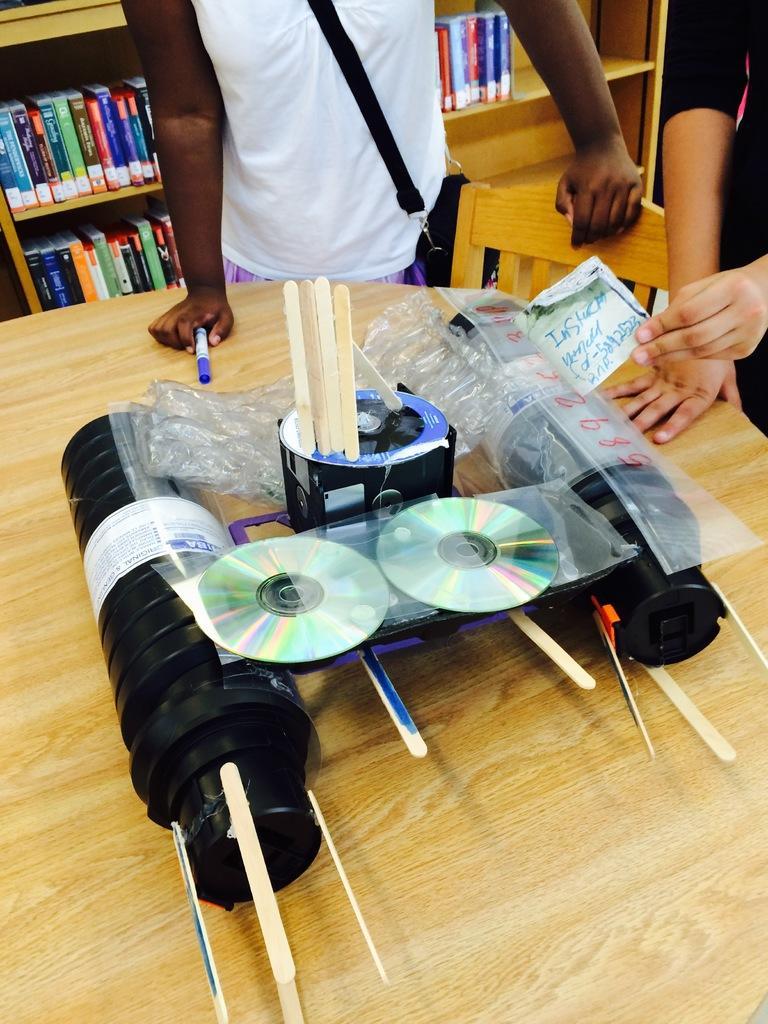Can you describe this image briefly? In this image there are two person standing beside a round table and a chair. On the table we can see a bottle, cds, sticks, paper and pen. On the background we can see is shelf on which there is a books. 